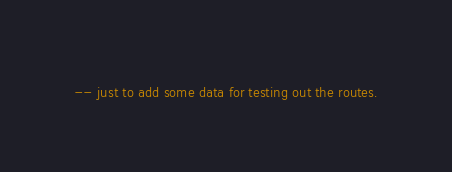Convert code to text. <code><loc_0><loc_0><loc_500><loc_500><_SQL_>-- just to add some data for testing out the routes.</code> 